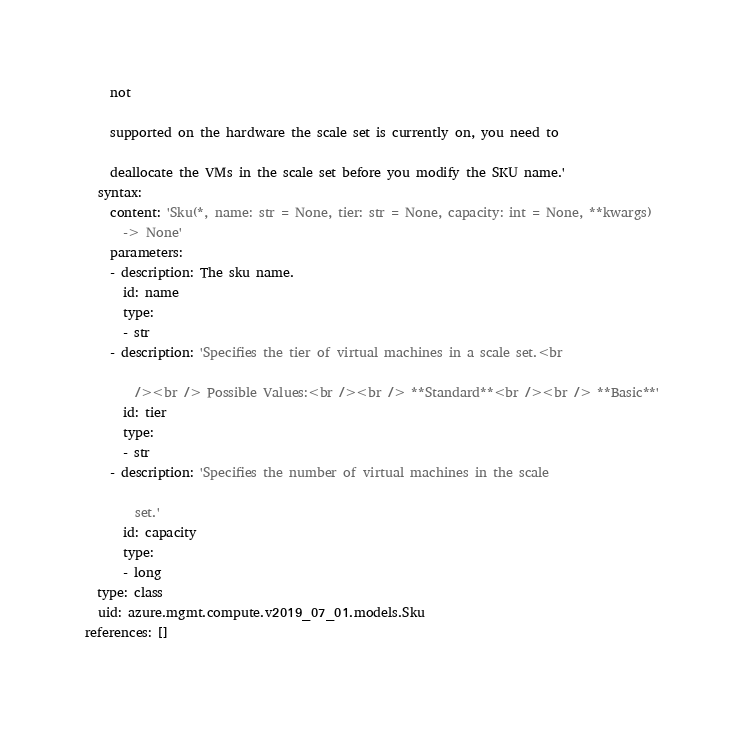Convert code to text. <code><loc_0><loc_0><loc_500><loc_500><_YAML_>    not

    supported on the hardware the scale set is currently on, you need to

    deallocate the VMs in the scale set before you modify the SKU name.'
  syntax:
    content: 'Sku(*, name: str = None, tier: str = None, capacity: int = None, **kwargs)
      -> None'
    parameters:
    - description: The sku name.
      id: name
      type:
      - str
    - description: 'Specifies the tier of virtual machines in a scale set.<br

        /><br /> Possible Values:<br /><br /> **Standard**<br /><br /> **Basic**'
      id: tier
      type:
      - str
    - description: 'Specifies the number of virtual machines in the scale

        set.'
      id: capacity
      type:
      - long
  type: class
  uid: azure.mgmt.compute.v2019_07_01.models.Sku
references: []
</code> 